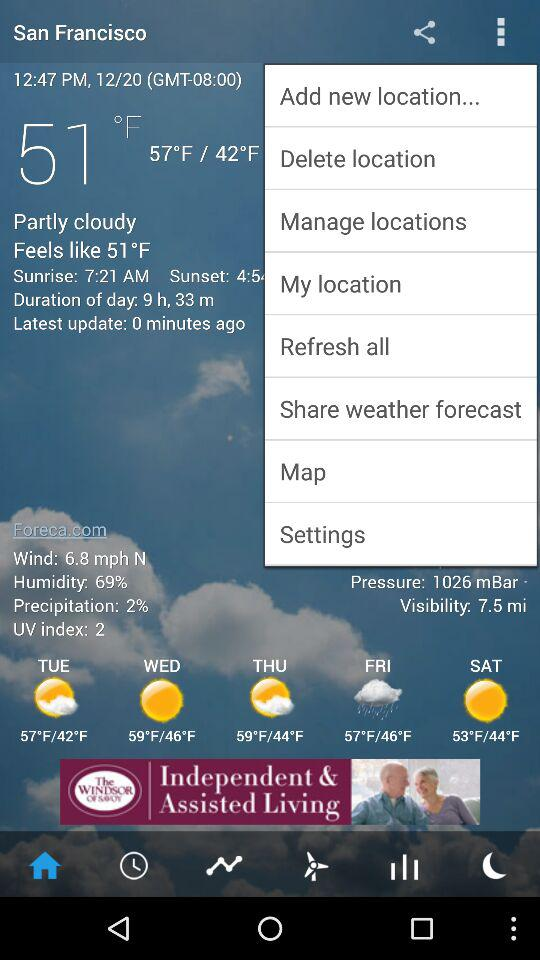How many minutes ago was the last update done? The last update was done 0 minutes ago. 